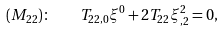Convert formula to latex. <formula><loc_0><loc_0><loc_500><loc_500>( M _ { 2 2 } ) \colon \quad T _ { 2 2 , 0 } \xi ^ { 0 } + 2 T _ { 2 2 } \xi ^ { 2 } _ { , 2 } = 0 ,</formula> 